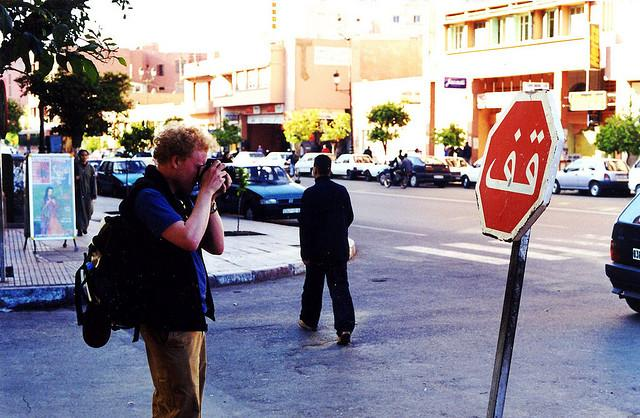What country is this? saudi arabia 